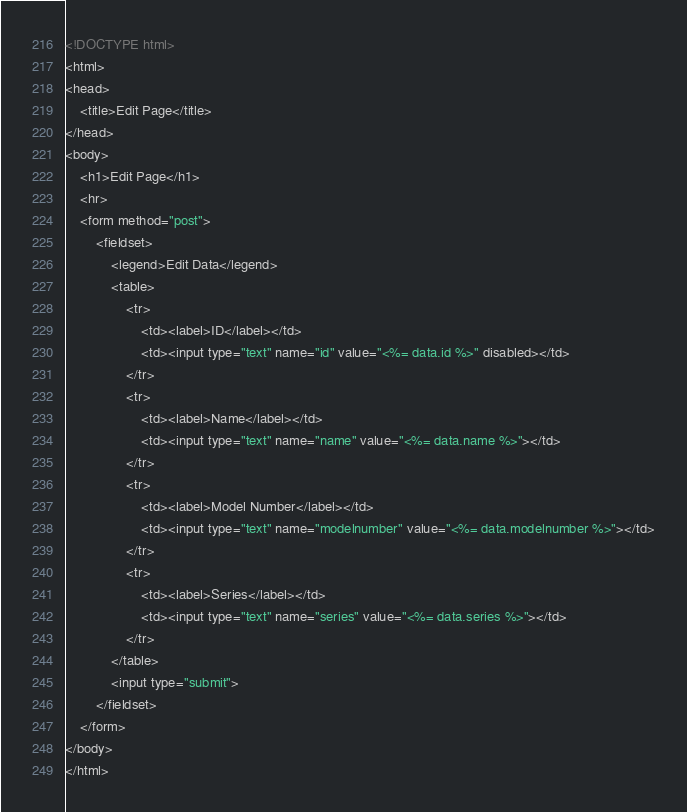Convert code to text. <code><loc_0><loc_0><loc_500><loc_500><_HTML_><!DOCTYPE html>
<html>
<head>
    <title>Edit Page</title>
</head>
<body>
    <h1>Edit Page</h1>
    <hr>
    <form method="post">
        <fieldset>
            <legend>Edit Data</legend>
            <table>
                <tr>
                    <td><label>ID</label></td>
                    <td><input type="text" name="id" value="<%= data.id %>" disabled></td>
                </tr>
                <tr>
                    <td><label>Name</label></td>
                    <td><input type="text" name="name" value="<%= data.name %>"></td>
                </tr>
                <tr>
                    <td><label>Model Number</label></td>
                    <td><input type="text" name="modelnumber" value="<%= data.modelnumber %>"></td>
                </tr>
                <tr>
                    <td><label>Series</label></td>
                    <td><input type="text" name="series" value="<%= data.series %>"></td>
                </tr>
            </table>
            <input type="submit">
        </fieldset>
    </form>
</body>
</html></code> 